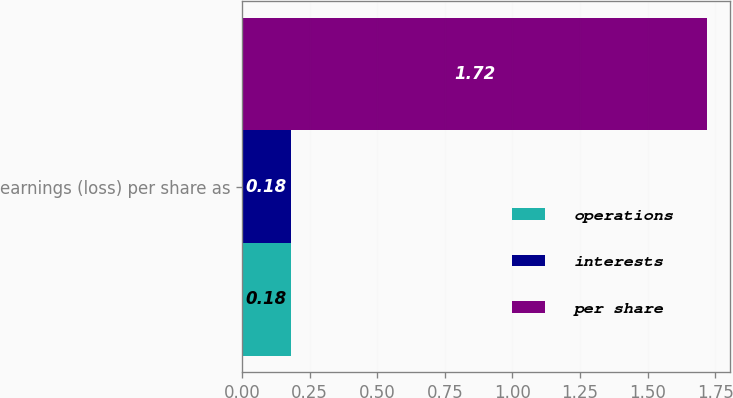<chart> <loc_0><loc_0><loc_500><loc_500><stacked_bar_chart><ecel><fcel>earnings (loss) per share as<nl><fcel>operations<fcel>0.18<nl><fcel>interests<fcel>0.18<nl><fcel>per share<fcel>1.72<nl></chart> 